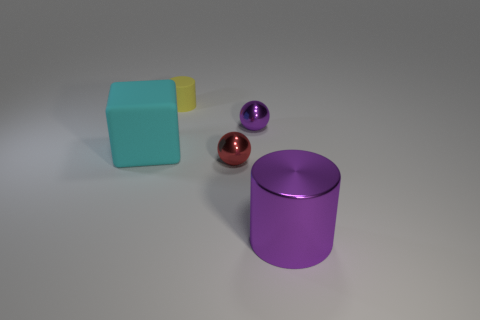Add 4 small blue shiny balls. How many objects exist? 9 Subtract all blocks. How many objects are left? 4 Add 1 large cyan cubes. How many large cyan cubes are left? 2 Add 3 red objects. How many red objects exist? 4 Subtract 0 red cylinders. How many objects are left? 5 Subtract all cylinders. Subtract all cyan rubber objects. How many objects are left? 2 